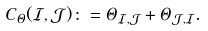<formula> <loc_0><loc_0><loc_500><loc_500>C _ { \Theta } ( { \mathcal { I } } , { \mathcal { J } } ) \colon = \Theta _ { { \mathcal { I } } , { \mathcal { J } } } + \Theta _ { { \mathcal { J } } , { \mathcal { I } } } .</formula> 